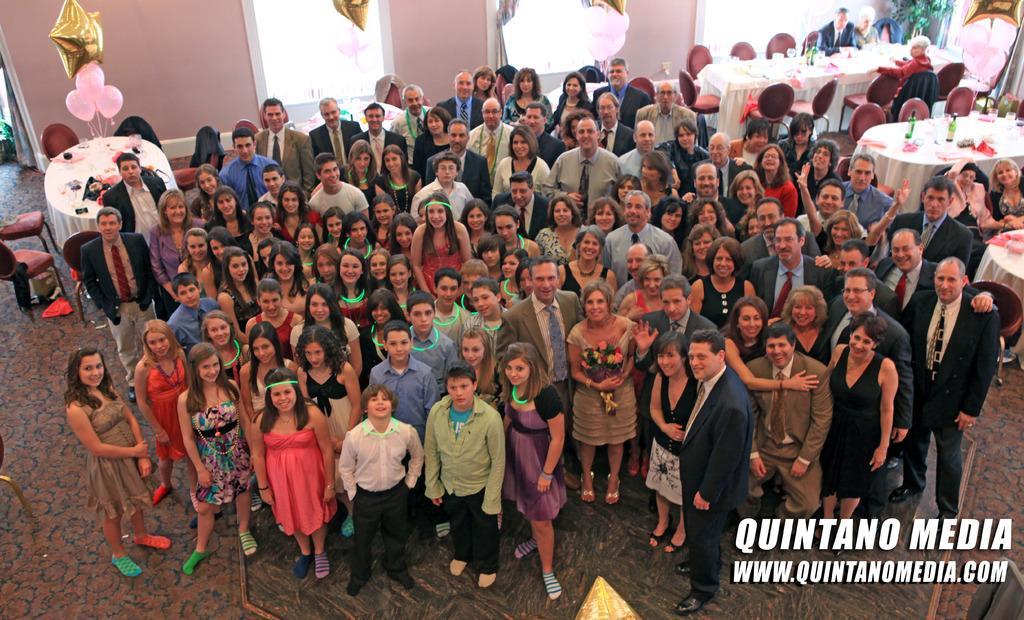How would you summarize this image in a sentence or two? In the image there are a lot of people standing and posing for the photo, behind them there are tables and chairs. In the background there are windows in between the wall. 